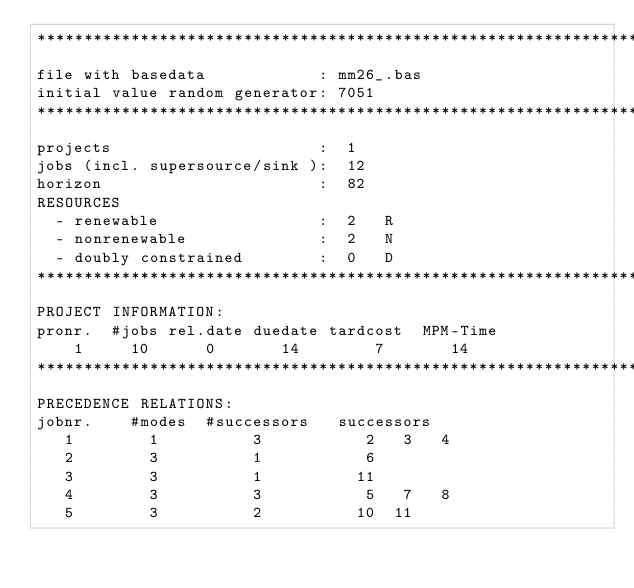<code> <loc_0><loc_0><loc_500><loc_500><_ObjectiveC_>************************************************************************
file with basedata            : mm26_.bas
initial value random generator: 7051
************************************************************************
projects                      :  1
jobs (incl. supersource/sink ):  12
horizon                       :  82
RESOURCES
  - renewable                 :  2   R
  - nonrenewable              :  2   N
  - doubly constrained        :  0   D
************************************************************************
PROJECT INFORMATION:
pronr.  #jobs rel.date duedate tardcost  MPM-Time
    1     10      0       14        7       14
************************************************************************
PRECEDENCE RELATIONS:
jobnr.    #modes  #successors   successors
   1        1          3           2   3   4
   2        3          1           6
   3        3          1          11
   4        3          3           5   7   8
   5        3          2          10  11</code> 